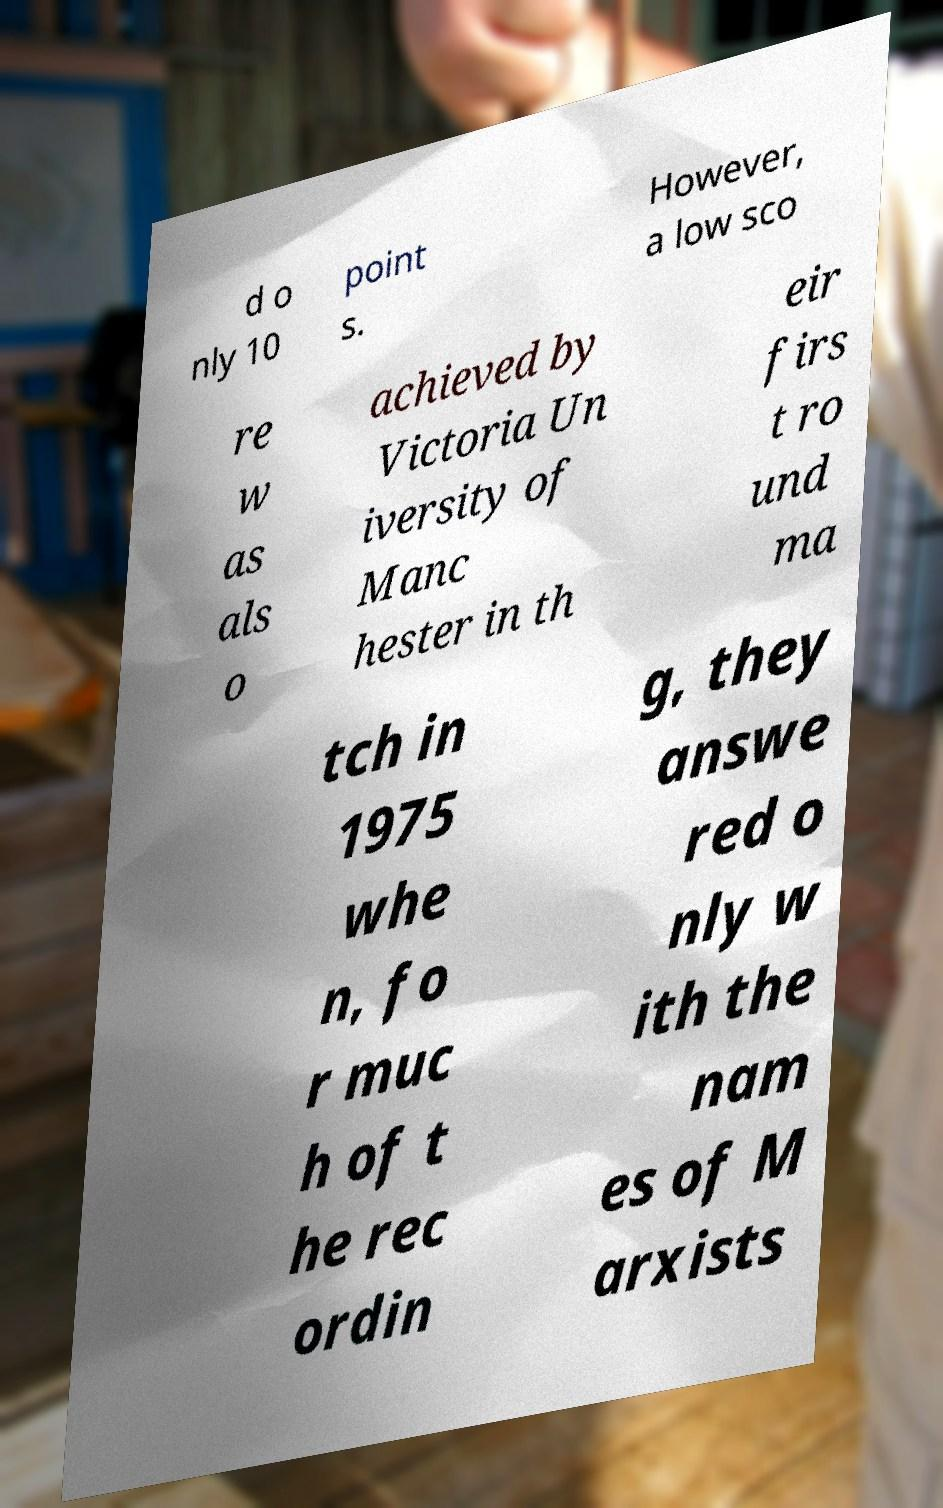Please read and relay the text visible in this image. What does it say? d o nly 10 point s. However, a low sco re w as als o achieved by Victoria Un iversity of Manc hester in th eir firs t ro und ma tch in 1975 whe n, fo r muc h of t he rec ordin g, they answe red o nly w ith the nam es of M arxists 